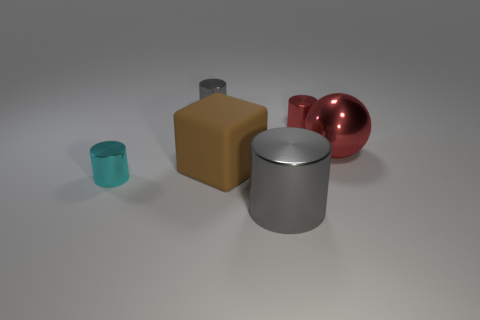How many objects are both in front of the large brown block and to the right of the small gray cylinder?
Offer a terse response. 1. The object that is the same color as the big metallic ball is what shape?
Provide a short and direct response. Cylinder. What is the material of the cylinder that is to the right of the tiny cyan metal thing and in front of the red ball?
Give a very brief answer. Metal. Is the number of small red metallic cylinders that are to the left of the tiny cyan shiny thing less than the number of tiny metal cylinders that are in front of the small red shiny object?
Ensure brevity in your answer.  Yes. The red cylinder that is made of the same material as the small cyan object is what size?
Offer a very short reply. Small. Is there any other thing that is the same color as the ball?
Offer a very short reply. Yes. Is the material of the big gray cylinder the same as the big thing that is left of the large cylinder?
Your answer should be compact. No. There is a tiny cyan thing that is the same shape as the large gray object; what material is it?
Your answer should be compact. Metal. Is there anything else that has the same material as the big brown block?
Offer a very short reply. No. Does the tiny thing in front of the red cylinder have the same material as the cube that is behind the tiny cyan metal object?
Offer a very short reply. No. 